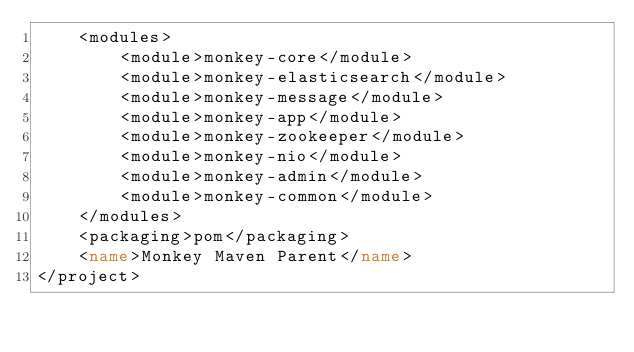Convert code to text. <code><loc_0><loc_0><loc_500><loc_500><_XML_>    <modules>
        <module>monkey-core</module>
        <module>monkey-elasticsearch</module>
        <module>monkey-message</module>
        <module>monkey-app</module>
        <module>monkey-zookeeper</module>
        <module>monkey-nio</module>
        <module>monkey-admin</module>
        <module>monkey-common</module>
    </modules>
    <packaging>pom</packaging>
    <name>Monkey Maven Parent</name>
</project></code> 